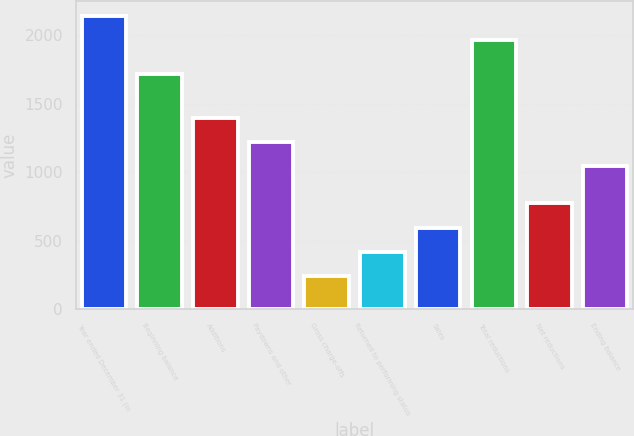Convert chart. <chart><loc_0><loc_0><loc_500><loc_500><bar_chart><fcel>Year ended December 31 (in<fcel>Beginning balance<fcel>Additions<fcel>Paydowns and other<fcel>Gross charge-offs<fcel>Returned to performing status<fcel>Sales<fcel>Total reductions<fcel>Net reductions<fcel>Ending balance<nl><fcel>2143.2<fcel>1717<fcel>1398.4<fcel>1221.2<fcel>241<fcel>418.2<fcel>595.4<fcel>1966<fcel>772.6<fcel>1044<nl></chart> 